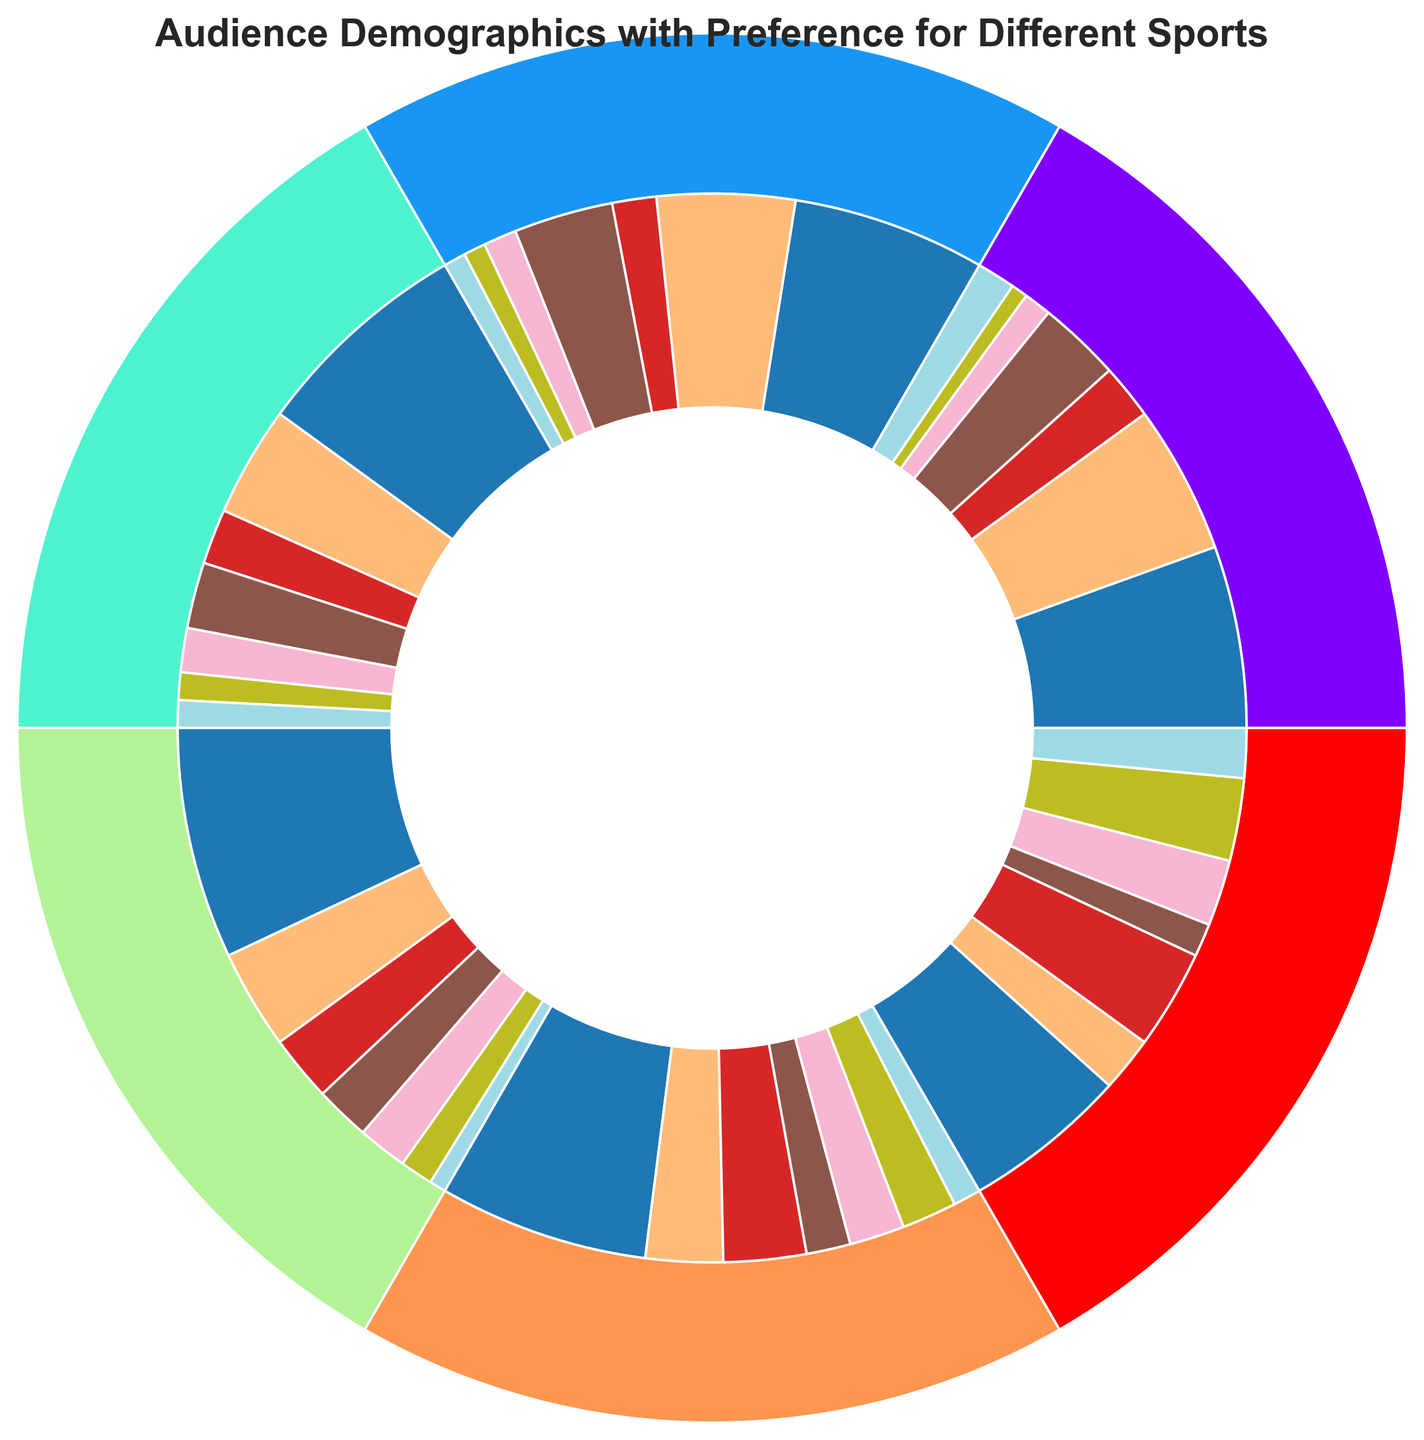What age group shows the highest preference for football? Look at the outer ring segments corresponding to different age groups and identify the one with the largest share going towards football in the inner ring. The biggest part in football is within the 45-54 age group.
Answer: 45-54 Which age group has the smallest preference for Golf? Check the inner ring for all segments corresponding to Golf and look for the smallest section. The smallest segment representing golf is within the 18-24 age group.
Answer: 18-24 How do Football preferences compare between the 18-24 and 65+ age groups? Identify the segments of the inner ring for Football within the 18-24 and 65+ age groups and compare their sizes. The Football segment is larger in the 18-24 age group compared to the 65+ age group.
Answer: 18-24 is higher Which sport has the highest preference among the 35-44 age group? Look for the largest segment in the inner ring corresponding to the 35-44 age group. The largest segment is for football.
Answer: Football Which age group shows an equal preference for Tennis and Golf? Identify the age group for which the Tennis and Golf segments in the inner ring are of equal size. Both segments are the same size in the 55-64 age group.
Answer: 55-64 Is the preference for Soccer higher among 25-34 or 55-64 age groups? Compare the sizes of the inner ring segments for Soccer between the 25-34 and 55-64 age groups. The Soccer segment is larger in the 25-34 age group.
Answer: 25-34 How does the preference for Basketball change as the age group increases? Observe the inner ring segments for Basketball across all age groups and track the change in segment sizes. Preference for Basketball decreases as the age group increases.
Answer: Decreases How many total preferences are there for sports among all age groups combined? Sum the values of all the segments in the chart. The total is the sum of all values listed.
Answer: 450 